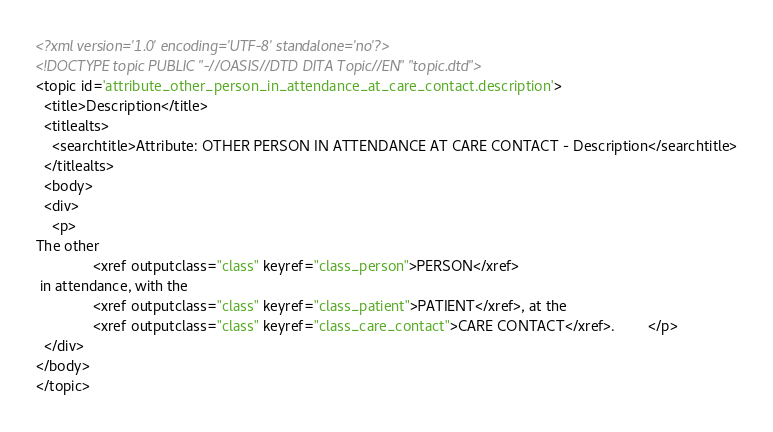Convert code to text. <code><loc_0><loc_0><loc_500><loc_500><_XML_><?xml version='1.0' encoding='UTF-8' standalone='no'?>
<!DOCTYPE topic PUBLIC "-//OASIS//DTD DITA Topic//EN" "topic.dtd">
<topic id='attribute_other_person_in_attendance_at_care_contact.description'>
  <title>Description</title>
  <titlealts>
    <searchtitle>Attribute: OTHER PERSON IN ATTENDANCE AT CARE CONTACT - Description</searchtitle>
  </titlealts>
  <body>
  <div>
    <p>
The other 
              <xref outputclass="class" keyref="class_person">PERSON</xref>
 in attendance, with the 
              <xref outputclass="class" keyref="class_patient">PATIENT</xref>, at the 
              <xref outputclass="class" keyref="class_care_contact">CARE CONTACT</xref>.        </p>
  </div>
</body>
</topic></code> 